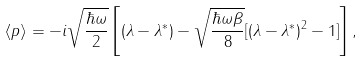<formula> <loc_0><loc_0><loc_500><loc_500>\langle p \rangle = - i \sqrt { \frac { \hbar { \omega } } { 2 } } \left [ ( \lambda - \lambda ^ { \ast } ) - \sqrt { \frac { \hbar { \omega } \beta } { 8 } } [ ( \lambda - \lambda ^ { \ast } ) ^ { 2 } - 1 ] \right ] ,</formula> 